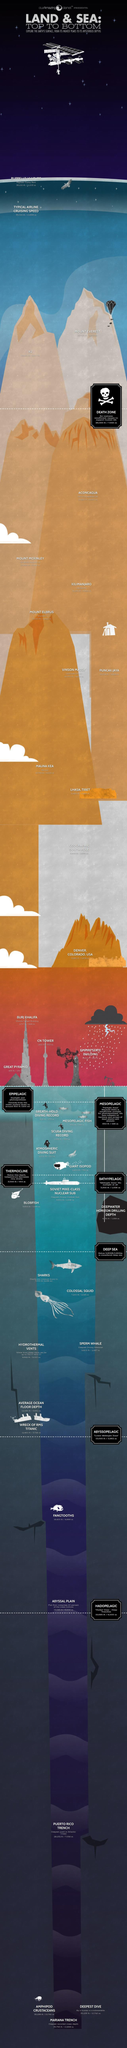Which is the mountain range located at 19,334 ft / 5,893 m?
Answer the question with a short phrase. Kilimanjaro At what height Death zone is located? 26,000 ft / 7,925 m What is the name of the point where the pressure of oxygen is insufficient to breath? Death Zone At what depth Hades zone is found? 19,685 ft / 6,000 m In which region Vinson Massif is located? Antarctica What is the name of the highest mountain? Mount Everest What is the name of the second highest mountain? K2 